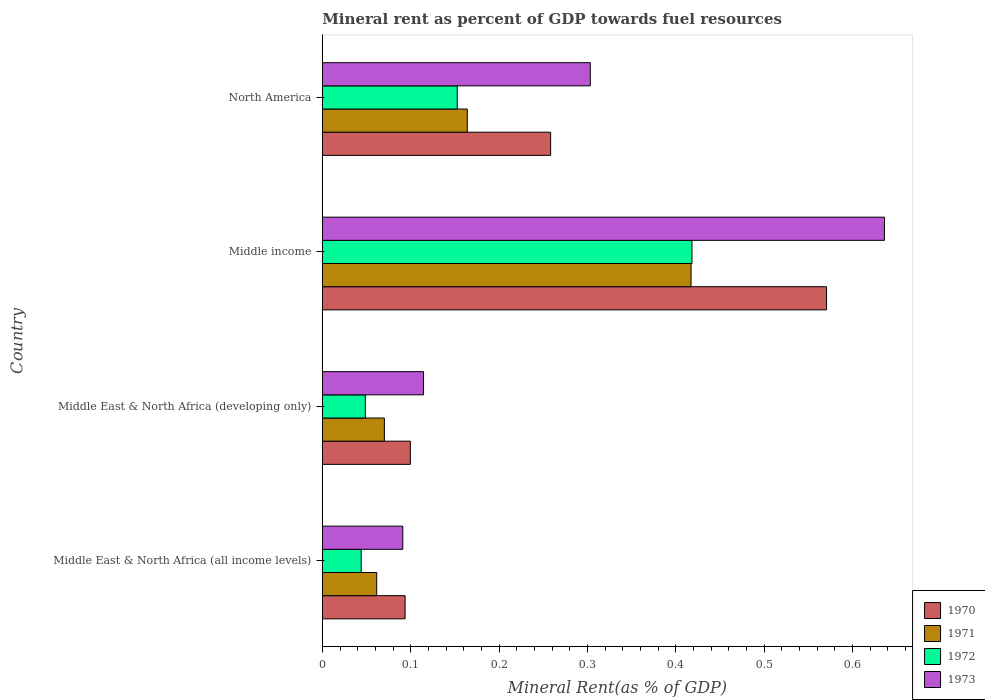How many groups of bars are there?
Your response must be concise. 4. How many bars are there on the 2nd tick from the top?
Provide a succinct answer. 4. In how many cases, is the number of bars for a given country not equal to the number of legend labels?
Offer a very short reply. 0. What is the mineral rent in 1971 in Middle East & North Africa (all income levels)?
Offer a terse response. 0.06. Across all countries, what is the maximum mineral rent in 1972?
Your answer should be very brief. 0.42. Across all countries, what is the minimum mineral rent in 1972?
Your answer should be compact. 0.04. In which country was the mineral rent in 1973 maximum?
Your response must be concise. Middle income. In which country was the mineral rent in 1971 minimum?
Your answer should be compact. Middle East & North Africa (all income levels). What is the total mineral rent in 1973 in the graph?
Your answer should be compact. 1.14. What is the difference between the mineral rent in 1971 in Middle East & North Africa (developing only) and that in Middle income?
Provide a short and direct response. -0.35. What is the difference between the mineral rent in 1972 in Middle East & North Africa (all income levels) and the mineral rent in 1971 in North America?
Provide a short and direct response. -0.12. What is the average mineral rent in 1972 per country?
Provide a short and direct response. 0.17. What is the difference between the mineral rent in 1970 and mineral rent in 1972 in Middle income?
Offer a very short reply. 0.15. In how many countries, is the mineral rent in 1972 greater than 0.5 %?
Provide a succinct answer. 0. What is the ratio of the mineral rent in 1971 in Middle East & North Africa (developing only) to that in Middle income?
Give a very brief answer. 0.17. What is the difference between the highest and the second highest mineral rent in 1970?
Provide a short and direct response. 0.31. What is the difference between the highest and the lowest mineral rent in 1971?
Keep it short and to the point. 0.36. Is the sum of the mineral rent in 1971 in Middle East & North Africa (developing only) and Middle income greater than the maximum mineral rent in 1973 across all countries?
Give a very brief answer. No. What does the 3rd bar from the top in North America represents?
Offer a very short reply. 1971. Are all the bars in the graph horizontal?
Ensure brevity in your answer.  Yes. How many countries are there in the graph?
Give a very brief answer. 4. Are the values on the major ticks of X-axis written in scientific E-notation?
Give a very brief answer. No. Does the graph contain grids?
Keep it short and to the point. No. Where does the legend appear in the graph?
Provide a short and direct response. Bottom right. What is the title of the graph?
Your answer should be compact. Mineral rent as percent of GDP towards fuel resources. Does "1994" appear as one of the legend labels in the graph?
Provide a succinct answer. No. What is the label or title of the X-axis?
Provide a short and direct response. Mineral Rent(as % of GDP). What is the label or title of the Y-axis?
Give a very brief answer. Country. What is the Mineral Rent(as % of GDP) in 1970 in Middle East & North Africa (all income levels)?
Make the answer very short. 0.09. What is the Mineral Rent(as % of GDP) in 1971 in Middle East & North Africa (all income levels)?
Your answer should be compact. 0.06. What is the Mineral Rent(as % of GDP) in 1972 in Middle East & North Africa (all income levels)?
Offer a terse response. 0.04. What is the Mineral Rent(as % of GDP) of 1973 in Middle East & North Africa (all income levels)?
Your answer should be very brief. 0.09. What is the Mineral Rent(as % of GDP) in 1970 in Middle East & North Africa (developing only)?
Give a very brief answer. 0.1. What is the Mineral Rent(as % of GDP) of 1971 in Middle East & North Africa (developing only)?
Your answer should be compact. 0.07. What is the Mineral Rent(as % of GDP) of 1972 in Middle East & North Africa (developing only)?
Make the answer very short. 0.05. What is the Mineral Rent(as % of GDP) in 1973 in Middle East & North Africa (developing only)?
Give a very brief answer. 0.11. What is the Mineral Rent(as % of GDP) in 1970 in Middle income?
Your answer should be compact. 0.57. What is the Mineral Rent(as % of GDP) of 1971 in Middle income?
Ensure brevity in your answer.  0.42. What is the Mineral Rent(as % of GDP) of 1972 in Middle income?
Offer a very short reply. 0.42. What is the Mineral Rent(as % of GDP) of 1973 in Middle income?
Ensure brevity in your answer.  0.64. What is the Mineral Rent(as % of GDP) of 1970 in North America?
Provide a short and direct response. 0.26. What is the Mineral Rent(as % of GDP) of 1971 in North America?
Ensure brevity in your answer.  0.16. What is the Mineral Rent(as % of GDP) of 1972 in North America?
Ensure brevity in your answer.  0.15. What is the Mineral Rent(as % of GDP) of 1973 in North America?
Provide a succinct answer. 0.3. Across all countries, what is the maximum Mineral Rent(as % of GDP) in 1970?
Offer a very short reply. 0.57. Across all countries, what is the maximum Mineral Rent(as % of GDP) of 1971?
Give a very brief answer. 0.42. Across all countries, what is the maximum Mineral Rent(as % of GDP) in 1972?
Your answer should be compact. 0.42. Across all countries, what is the maximum Mineral Rent(as % of GDP) in 1973?
Provide a succinct answer. 0.64. Across all countries, what is the minimum Mineral Rent(as % of GDP) in 1970?
Offer a terse response. 0.09. Across all countries, what is the minimum Mineral Rent(as % of GDP) of 1971?
Your answer should be very brief. 0.06. Across all countries, what is the minimum Mineral Rent(as % of GDP) of 1972?
Ensure brevity in your answer.  0.04. Across all countries, what is the minimum Mineral Rent(as % of GDP) in 1973?
Your answer should be very brief. 0.09. What is the total Mineral Rent(as % of GDP) of 1970 in the graph?
Provide a short and direct response. 1.02. What is the total Mineral Rent(as % of GDP) in 1971 in the graph?
Offer a terse response. 0.71. What is the total Mineral Rent(as % of GDP) of 1972 in the graph?
Provide a short and direct response. 0.66. What is the total Mineral Rent(as % of GDP) of 1973 in the graph?
Provide a short and direct response. 1.14. What is the difference between the Mineral Rent(as % of GDP) of 1970 in Middle East & North Africa (all income levels) and that in Middle East & North Africa (developing only)?
Your response must be concise. -0.01. What is the difference between the Mineral Rent(as % of GDP) in 1971 in Middle East & North Africa (all income levels) and that in Middle East & North Africa (developing only)?
Provide a short and direct response. -0.01. What is the difference between the Mineral Rent(as % of GDP) of 1972 in Middle East & North Africa (all income levels) and that in Middle East & North Africa (developing only)?
Your answer should be very brief. -0. What is the difference between the Mineral Rent(as % of GDP) of 1973 in Middle East & North Africa (all income levels) and that in Middle East & North Africa (developing only)?
Provide a short and direct response. -0.02. What is the difference between the Mineral Rent(as % of GDP) in 1970 in Middle East & North Africa (all income levels) and that in Middle income?
Provide a short and direct response. -0.48. What is the difference between the Mineral Rent(as % of GDP) of 1971 in Middle East & North Africa (all income levels) and that in Middle income?
Provide a short and direct response. -0.36. What is the difference between the Mineral Rent(as % of GDP) in 1972 in Middle East & North Africa (all income levels) and that in Middle income?
Ensure brevity in your answer.  -0.37. What is the difference between the Mineral Rent(as % of GDP) in 1973 in Middle East & North Africa (all income levels) and that in Middle income?
Ensure brevity in your answer.  -0.55. What is the difference between the Mineral Rent(as % of GDP) of 1970 in Middle East & North Africa (all income levels) and that in North America?
Provide a succinct answer. -0.16. What is the difference between the Mineral Rent(as % of GDP) in 1971 in Middle East & North Africa (all income levels) and that in North America?
Offer a very short reply. -0.1. What is the difference between the Mineral Rent(as % of GDP) of 1972 in Middle East & North Africa (all income levels) and that in North America?
Give a very brief answer. -0.11. What is the difference between the Mineral Rent(as % of GDP) in 1973 in Middle East & North Africa (all income levels) and that in North America?
Offer a very short reply. -0.21. What is the difference between the Mineral Rent(as % of GDP) in 1970 in Middle East & North Africa (developing only) and that in Middle income?
Give a very brief answer. -0.47. What is the difference between the Mineral Rent(as % of GDP) in 1971 in Middle East & North Africa (developing only) and that in Middle income?
Offer a terse response. -0.35. What is the difference between the Mineral Rent(as % of GDP) of 1972 in Middle East & North Africa (developing only) and that in Middle income?
Provide a succinct answer. -0.37. What is the difference between the Mineral Rent(as % of GDP) of 1973 in Middle East & North Africa (developing only) and that in Middle income?
Make the answer very short. -0.52. What is the difference between the Mineral Rent(as % of GDP) of 1970 in Middle East & North Africa (developing only) and that in North America?
Your answer should be compact. -0.16. What is the difference between the Mineral Rent(as % of GDP) of 1971 in Middle East & North Africa (developing only) and that in North America?
Offer a very short reply. -0.09. What is the difference between the Mineral Rent(as % of GDP) in 1972 in Middle East & North Africa (developing only) and that in North America?
Provide a succinct answer. -0.1. What is the difference between the Mineral Rent(as % of GDP) of 1973 in Middle East & North Africa (developing only) and that in North America?
Your response must be concise. -0.19. What is the difference between the Mineral Rent(as % of GDP) of 1970 in Middle income and that in North America?
Offer a terse response. 0.31. What is the difference between the Mineral Rent(as % of GDP) in 1971 in Middle income and that in North America?
Your answer should be very brief. 0.25. What is the difference between the Mineral Rent(as % of GDP) in 1972 in Middle income and that in North America?
Offer a terse response. 0.27. What is the difference between the Mineral Rent(as % of GDP) in 1973 in Middle income and that in North America?
Offer a terse response. 0.33. What is the difference between the Mineral Rent(as % of GDP) in 1970 in Middle East & North Africa (all income levels) and the Mineral Rent(as % of GDP) in 1971 in Middle East & North Africa (developing only)?
Your response must be concise. 0.02. What is the difference between the Mineral Rent(as % of GDP) in 1970 in Middle East & North Africa (all income levels) and the Mineral Rent(as % of GDP) in 1972 in Middle East & North Africa (developing only)?
Your answer should be very brief. 0.04. What is the difference between the Mineral Rent(as % of GDP) of 1970 in Middle East & North Africa (all income levels) and the Mineral Rent(as % of GDP) of 1973 in Middle East & North Africa (developing only)?
Your answer should be compact. -0.02. What is the difference between the Mineral Rent(as % of GDP) in 1971 in Middle East & North Africa (all income levels) and the Mineral Rent(as % of GDP) in 1972 in Middle East & North Africa (developing only)?
Offer a terse response. 0.01. What is the difference between the Mineral Rent(as % of GDP) in 1971 in Middle East & North Africa (all income levels) and the Mineral Rent(as % of GDP) in 1973 in Middle East & North Africa (developing only)?
Make the answer very short. -0.05. What is the difference between the Mineral Rent(as % of GDP) of 1972 in Middle East & North Africa (all income levels) and the Mineral Rent(as % of GDP) of 1973 in Middle East & North Africa (developing only)?
Your answer should be very brief. -0.07. What is the difference between the Mineral Rent(as % of GDP) of 1970 in Middle East & North Africa (all income levels) and the Mineral Rent(as % of GDP) of 1971 in Middle income?
Provide a succinct answer. -0.32. What is the difference between the Mineral Rent(as % of GDP) in 1970 in Middle East & North Africa (all income levels) and the Mineral Rent(as % of GDP) in 1972 in Middle income?
Your answer should be very brief. -0.32. What is the difference between the Mineral Rent(as % of GDP) of 1970 in Middle East & North Africa (all income levels) and the Mineral Rent(as % of GDP) of 1973 in Middle income?
Offer a terse response. -0.54. What is the difference between the Mineral Rent(as % of GDP) of 1971 in Middle East & North Africa (all income levels) and the Mineral Rent(as % of GDP) of 1972 in Middle income?
Your answer should be compact. -0.36. What is the difference between the Mineral Rent(as % of GDP) in 1971 in Middle East & North Africa (all income levels) and the Mineral Rent(as % of GDP) in 1973 in Middle income?
Keep it short and to the point. -0.57. What is the difference between the Mineral Rent(as % of GDP) of 1972 in Middle East & North Africa (all income levels) and the Mineral Rent(as % of GDP) of 1973 in Middle income?
Offer a terse response. -0.59. What is the difference between the Mineral Rent(as % of GDP) of 1970 in Middle East & North Africa (all income levels) and the Mineral Rent(as % of GDP) of 1971 in North America?
Provide a succinct answer. -0.07. What is the difference between the Mineral Rent(as % of GDP) of 1970 in Middle East & North Africa (all income levels) and the Mineral Rent(as % of GDP) of 1972 in North America?
Provide a succinct answer. -0.06. What is the difference between the Mineral Rent(as % of GDP) in 1970 in Middle East & North Africa (all income levels) and the Mineral Rent(as % of GDP) in 1973 in North America?
Provide a succinct answer. -0.21. What is the difference between the Mineral Rent(as % of GDP) in 1971 in Middle East & North Africa (all income levels) and the Mineral Rent(as % of GDP) in 1972 in North America?
Provide a succinct answer. -0.09. What is the difference between the Mineral Rent(as % of GDP) of 1971 in Middle East & North Africa (all income levels) and the Mineral Rent(as % of GDP) of 1973 in North America?
Ensure brevity in your answer.  -0.24. What is the difference between the Mineral Rent(as % of GDP) in 1972 in Middle East & North Africa (all income levels) and the Mineral Rent(as % of GDP) in 1973 in North America?
Your answer should be compact. -0.26. What is the difference between the Mineral Rent(as % of GDP) of 1970 in Middle East & North Africa (developing only) and the Mineral Rent(as % of GDP) of 1971 in Middle income?
Ensure brevity in your answer.  -0.32. What is the difference between the Mineral Rent(as % of GDP) in 1970 in Middle East & North Africa (developing only) and the Mineral Rent(as % of GDP) in 1972 in Middle income?
Your answer should be compact. -0.32. What is the difference between the Mineral Rent(as % of GDP) of 1970 in Middle East & North Africa (developing only) and the Mineral Rent(as % of GDP) of 1973 in Middle income?
Ensure brevity in your answer.  -0.54. What is the difference between the Mineral Rent(as % of GDP) of 1971 in Middle East & North Africa (developing only) and the Mineral Rent(as % of GDP) of 1972 in Middle income?
Ensure brevity in your answer.  -0.35. What is the difference between the Mineral Rent(as % of GDP) in 1971 in Middle East & North Africa (developing only) and the Mineral Rent(as % of GDP) in 1973 in Middle income?
Your answer should be very brief. -0.57. What is the difference between the Mineral Rent(as % of GDP) in 1972 in Middle East & North Africa (developing only) and the Mineral Rent(as % of GDP) in 1973 in Middle income?
Give a very brief answer. -0.59. What is the difference between the Mineral Rent(as % of GDP) of 1970 in Middle East & North Africa (developing only) and the Mineral Rent(as % of GDP) of 1971 in North America?
Keep it short and to the point. -0.06. What is the difference between the Mineral Rent(as % of GDP) in 1970 in Middle East & North Africa (developing only) and the Mineral Rent(as % of GDP) in 1972 in North America?
Provide a succinct answer. -0.05. What is the difference between the Mineral Rent(as % of GDP) of 1970 in Middle East & North Africa (developing only) and the Mineral Rent(as % of GDP) of 1973 in North America?
Provide a succinct answer. -0.2. What is the difference between the Mineral Rent(as % of GDP) of 1971 in Middle East & North Africa (developing only) and the Mineral Rent(as % of GDP) of 1972 in North America?
Provide a short and direct response. -0.08. What is the difference between the Mineral Rent(as % of GDP) in 1971 in Middle East & North Africa (developing only) and the Mineral Rent(as % of GDP) in 1973 in North America?
Ensure brevity in your answer.  -0.23. What is the difference between the Mineral Rent(as % of GDP) in 1972 in Middle East & North Africa (developing only) and the Mineral Rent(as % of GDP) in 1973 in North America?
Keep it short and to the point. -0.25. What is the difference between the Mineral Rent(as % of GDP) of 1970 in Middle income and the Mineral Rent(as % of GDP) of 1971 in North America?
Your answer should be compact. 0.41. What is the difference between the Mineral Rent(as % of GDP) of 1970 in Middle income and the Mineral Rent(as % of GDP) of 1972 in North America?
Provide a short and direct response. 0.42. What is the difference between the Mineral Rent(as % of GDP) in 1970 in Middle income and the Mineral Rent(as % of GDP) in 1973 in North America?
Your answer should be very brief. 0.27. What is the difference between the Mineral Rent(as % of GDP) in 1971 in Middle income and the Mineral Rent(as % of GDP) in 1972 in North America?
Offer a very short reply. 0.26. What is the difference between the Mineral Rent(as % of GDP) in 1971 in Middle income and the Mineral Rent(as % of GDP) in 1973 in North America?
Your answer should be very brief. 0.11. What is the difference between the Mineral Rent(as % of GDP) of 1972 in Middle income and the Mineral Rent(as % of GDP) of 1973 in North America?
Make the answer very short. 0.12. What is the average Mineral Rent(as % of GDP) in 1970 per country?
Make the answer very short. 0.26. What is the average Mineral Rent(as % of GDP) in 1971 per country?
Keep it short and to the point. 0.18. What is the average Mineral Rent(as % of GDP) of 1972 per country?
Keep it short and to the point. 0.17. What is the average Mineral Rent(as % of GDP) in 1973 per country?
Provide a short and direct response. 0.29. What is the difference between the Mineral Rent(as % of GDP) in 1970 and Mineral Rent(as % of GDP) in 1971 in Middle East & North Africa (all income levels)?
Your answer should be compact. 0.03. What is the difference between the Mineral Rent(as % of GDP) of 1970 and Mineral Rent(as % of GDP) of 1972 in Middle East & North Africa (all income levels)?
Provide a short and direct response. 0.05. What is the difference between the Mineral Rent(as % of GDP) in 1970 and Mineral Rent(as % of GDP) in 1973 in Middle East & North Africa (all income levels)?
Your answer should be compact. 0. What is the difference between the Mineral Rent(as % of GDP) of 1971 and Mineral Rent(as % of GDP) of 1972 in Middle East & North Africa (all income levels)?
Keep it short and to the point. 0.02. What is the difference between the Mineral Rent(as % of GDP) of 1971 and Mineral Rent(as % of GDP) of 1973 in Middle East & North Africa (all income levels)?
Your answer should be compact. -0.03. What is the difference between the Mineral Rent(as % of GDP) of 1972 and Mineral Rent(as % of GDP) of 1973 in Middle East & North Africa (all income levels)?
Keep it short and to the point. -0.05. What is the difference between the Mineral Rent(as % of GDP) in 1970 and Mineral Rent(as % of GDP) in 1971 in Middle East & North Africa (developing only)?
Your answer should be compact. 0.03. What is the difference between the Mineral Rent(as % of GDP) of 1970 and Mineral Rent(as % of GDP) of 1972 in Middle East & North Africa (developing only)?
Provide a short and direct response. 0.05. What is the difference between the Mineral Rent(as % of GDP) of 1970 and Mineral Rent(as % of GDP) of 1973 in Middle East & North Africa (developing only)?
Offer a very short reply. -0.01. What is the difference between the Mineral Rent(as % of GDP) of 1971 and Mineral Rent(as % of GDP) of 1972 in Middle East & North Africa (developing only)?
Your response must be concise. 0.02. What is the difference between the Mineral Rent(as % of GDP) in 1971 and Mineral Rent(as % of GDP) in 1973 in Middle East & North Africa (developing only)?
Keep it short and to the point. -0.04. What is the difference between the Mineral Rent(as % of GDP) of 1972 and Mineral Rent(as % of GDP) of 1973 in Middle East & North Africa (developing only)?
Make the answer very short. -0.07. What is the difference between the Mineral Rent(as % of GDP) of 1970 and Mineral Rent(as % of GDP) of 1971 in Middle income?
Provide a short and direct response. 0.15. What is the difference between the Mineral Rent(as % of GDP) of 1970 and Mineral Rent(as % of GDP) of 1972 in Middle income?
Your answer should be very brief. 0.15. What is the difference between the Mineral Rent(as % of GDP) in 1970 and Mineral Rent(as % of GDP) in 1973 in Middle income?
Offer a terse response. -0.07. What is the difference between the Mineral Rent(as % of GDP) in 1971 and Mineral Rent(as % of GDP) in 1972 in Middle income?
Give a very brief answer. -0. What is the difference between the Mineral Rent(as % of GDP) of 1971 and Mineral Rent(as % of GDP) of 1973 in Middle income?
Ensure brevity in your answer.  -0.22. What is the difference between the Mineral Rent(as % of GDP) in 1972 and Mineral Rent(as % of GDP) in 1973 in Middle income?
Your response must be concise. -0.22. What is the difference between the Mineral Rent(as % of GDP) in 1970 and Mineral Rent(as % of GDP) in 1971 in North America?
Offer a terse response. 0.09. What is the difference between the Mineral Rent(as % of GDP) of 1970 and Mineral Rent(as % of GDP) of 1972 in North America?
Ensure brevity in your answer.  0.11. What is the difference between the Mineral Rent(as % of GDP) of 1970 and Mineral Rent(as % of GDP) of 1973 in North America?
Your answer should be very brief. -0.04. What is the difference between the Mineral Rent(as % of GDP) in 1971 and Mineral Rent(as % of GDP) in 1972 in North America?
Your response must be concise. 0.01. What is the difference between the Mineral Rent(as % of GDP) in 1971 and Mineral Rent(as % of GDP) in 1973 in North America?
Your answer should be compact. -0.14. What is the difference between the Mineral Rent(as % of GDP) in 1972 and Mineral Rent(as % of GDP) in 1973 in North America?
Your response must be concise. -0.15. What is the ratio of the Mineral Rent(as % of GDP) in 1970 in Middle East & North Africa (all income levels) to that in Middle East & North Africa (developing only)?
Provide a succinct answer. 0.94. What is the ratio of the Mineral Rent(as % of GDP) in 1971 in Middle East & North Africa (all income levels) to that in Middle East & North Africa (developing only)?
Offer a very short reply. 0.88. What is the ratio of the Mineral Rent(as % of GDP) in 1972 in Middle East & North Africa (all income levels) to that in Middle East & North Africa (developing only)?
Offer a terse response. 0.9. What is the ratio of the Mineral Rent(as % of GDP) of 1973 in Middle East & North Africa (all income levels) to that in Middle East & North Africa (developing only)?
Offer a terse response. 0.8. What is the ratio of the Mineral Rent(as % of GDP) of 1970 in Middle East & North Africa (all income levels) to that in Middle income?
Offer a very short reply. 0.16. What is the ratio of the Mineral Rent(as % of GDP) of 1971 in Middle East & North Africa (all income levels) to that in Middle income?
Offer a terse response. 0.15. What is the ratio of the Mineral Rent(as % of GDP) in 1972 in Middle East & North Africa (all income levels) to that in Middle income?
Your response must be concise. 0.11. What is the ratio of the Mineral Rent(as % of GDP) in 1973 in Middle East & North Africa (all income levels) to that in Middle income?
Provide a succinct answer. 0.14. What is the ratio of the Mineral Rent(as % of GDP) of 1970 in Middle East & North Africa (all income levels) to that in North America?
Your response must be concise. 0.36. What is the ratio of the Mineral Rent(as % of GDP) of 1972 in Middle East & North Africa (all income levels) to that in North America?
Your answer should be compact. 0.29. What is the ratio of the Mineral Rent(as % of GDP) of 1973 in Middle East & North Africa (all income levels) to that in North America?
Your response must be concise. 0.3. What is the ratio of the Mineral Rent(as % of GDP) in 1970 in Middle East & North Africa (developing only) to that in Middle income?
Offer a very short reply. 0.17. What is the ratio of the Mineral Rent(as % of GDP) in 1971 in Middle East & North Africa (developing only) to that in Middle income?
Offer a very short reply. 0.17. What is the ratio of the Mineral Rent(as % of GDP) of 1972 in Middle East & North Africa (developing only) to that in Middle income?
Ensure brevity in your answer.  0.12. What is the ratio of the Mineral Rent(as % of GDP) of 1973 in Middle East & North Africa (developing only) to that in Middle income?
Give a very brief answer. 0.18. What is the ratio of the Mineral Rent(as % of GDP) of 1970 in Middle East & North Africa (developing only) to that in North America?
Ensure brevity in your answer.  0.39. What is the ratio of the Mineral Rent(as % of GDP) of 1971 in Middle East & North Africa (developing only) to that in North America?
Make the answer very short. 0.43. What is the ratio of the Mineral Rent(as % of GDP) in 1972 in Middle East & North Africa (developing only) to that in North America?
Give a very brief answer. 0.32. What is the ratio of the Mineral Rent(as % of GDP) in 1973 in Middle East & North Africa (developing only) to that in North America?
Your answer should be very brief. 0.38. What is the ratio of the Mineral Rent(as % of GDP) in 1970 in Middle income to that in North America?
Give a very brief answer. 2.21. What is the ratio of the Mineral Rent(as % of GDP) of 1971 in Middle income to that in North America?
Offer a very short reply. 2.54. What is the ratio of the Mineral Rent(as % of GDP) in 1972 in Middle income to that in North America?
Your answer should be compact. 2.74. What is the ratio of the Mineral Rent(as % of GDP) in 1973 in Middle income to that in North America?
Provide a succinct answer. 2.1. What is the difference between the highest and the second highest Mineral Rent(as % of GDP) in 1970?
Offer a very short reply. 0.31. What is the difference between the highest and the second highest Mineral Rent(as % of GDP) of 1971?
Make the answer very short. 0.25. What is the difference between the highest and the second highest Mineral Rent(as % of GDP) of 1972?
Offer a terse response. 0.27. What is the difference between the highest and the second highest Mineral Rent(as % of GDP) of 1973?
Provide a succinct answer. 0.33. What is the difference between the highest and the lowest Mineral Rent(as % of GDP) in 1970?
Make the answer very short. 0.48. What is the difference between the highest and the lowest Mineral Rent(as % of GDP) of 1971?
Offer a terse response. 0.36. What is the difference between the highest and the lowest Mineral Rent(as % of GDP) of 1972?
Give a very brief answer. 0.37. What is the difference between the highest and the lowest Mineral Rent(as % of GDP) in 1973?
Offer a terse response. 0.55. 